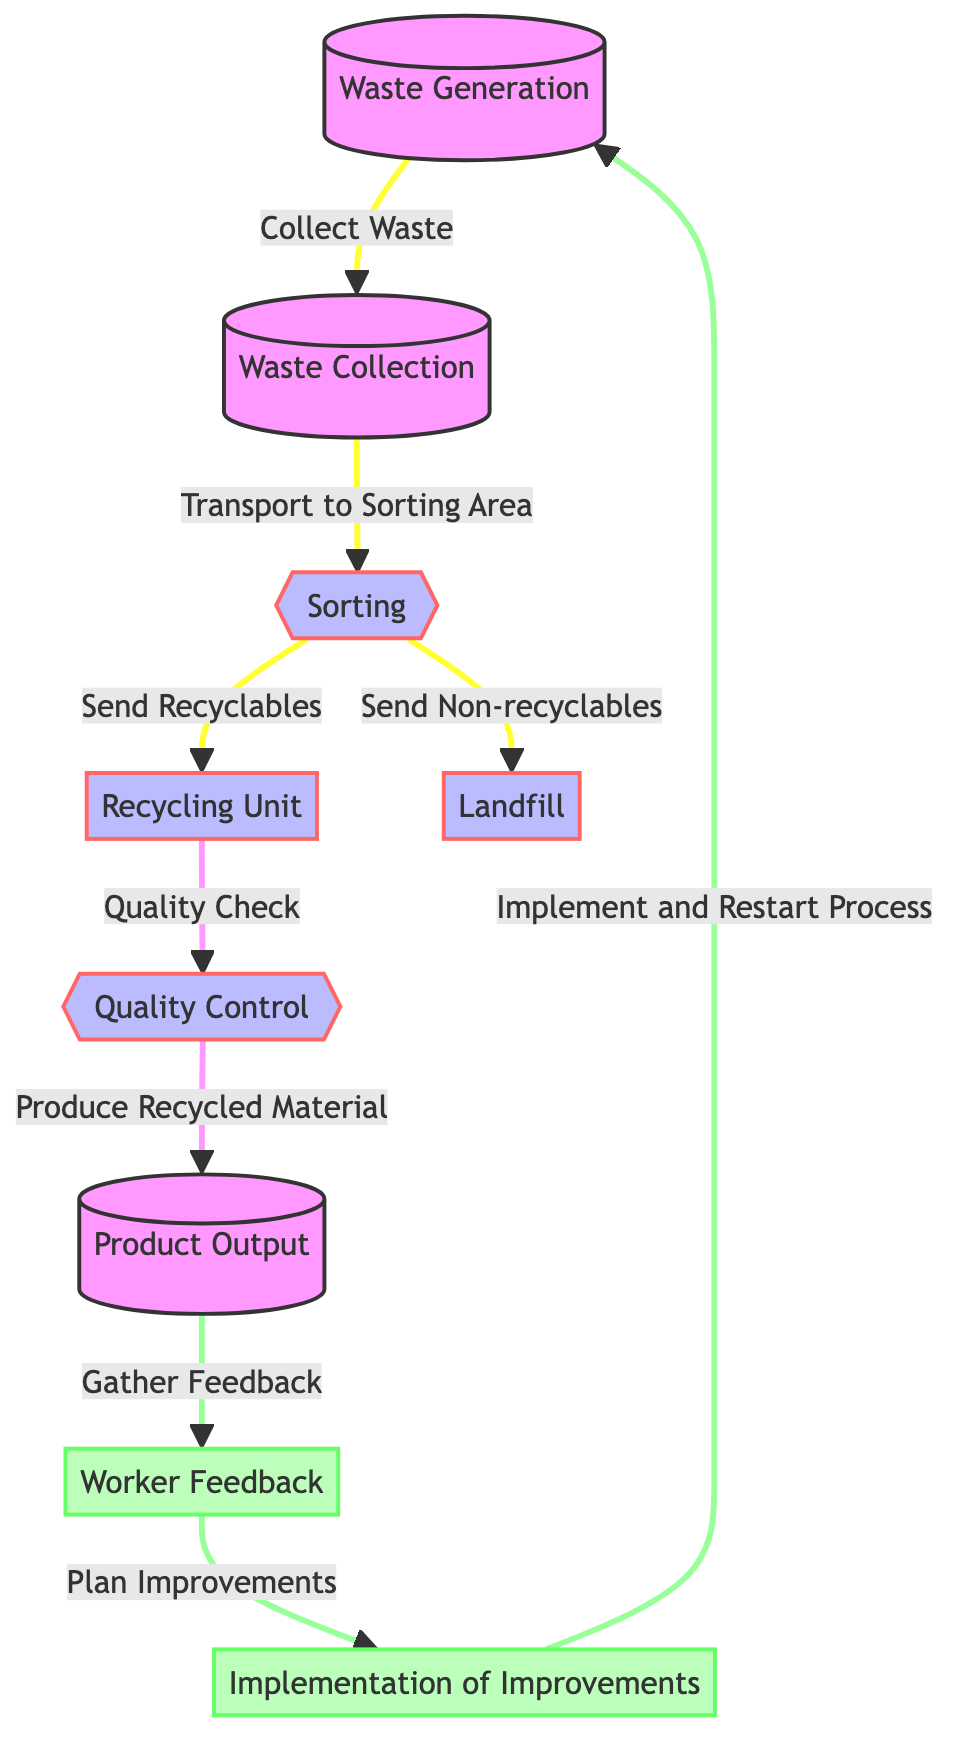What is the first step in the waste management process? The diagram starts with "Waste Generation" as the first node, indicating it is the initial step where waste is produced.
Answer: Waste Generation How many nodes are in the process flow? By counting each distinct node in the diagram, there are a total of 9 nodes involved in the waste management and recycling process.
Answer: 9 What two outcomes result from the sorting stage? The sorting stage sends outputs to two distinct nodes: one for recyclables leading to the Recycling Unit, and the other for non-recyclables leading to the Landfill.
Answer: Send Recyclables and Send Non-recyclables What happens after quality control? Following the quality control step, the process produces recycled material, which is represented in the diagram by the node labeled "Product Output."
Answer: Produce Recycled Material What is the feedback loop after product output? After "Product Output," there is a loop that gathers worker feedback, which leads to planning improvements, then those improvements are implemented, and the process restarts.
Answer: Worker Feedback How many different feedback actions are there? There are two feedback-related actions in the diagram: "Gather Feedback" and "Plan Improvements." These are the distinct feedback actions represented.
Answer: 2 At what stage are improvements planned? Improvements are planned immediately after gathering worker feedback, as shown by the flow from "Gather Feedback" to "Plan Improvements."
Answer: Plan Improvements Which nodes are classified as feedback? The feedback nodes in the diagram are "Worker Feedback" and "Implementation of Improvements," indicating that these focus on gathering and implementing feedback.
Answer: Worker Feedback and Implementation of Improvements What is the last step before restarting the waste management process? The final step before restarting the process is "Implementation of Improvements," which occurs after planning improvements based on feedback.
Answer: Implementation of Improvements 